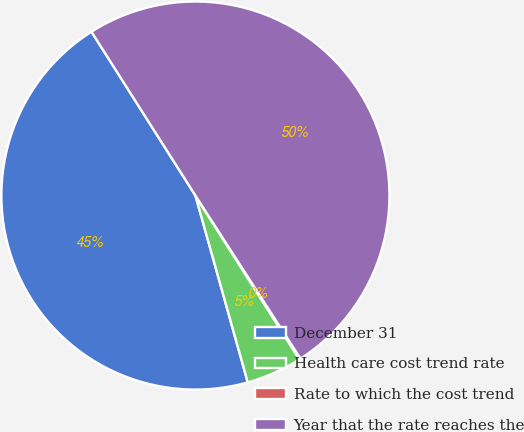Convert chart to OTSL. <chart><loc_0><loc_0><loc_500><loc_500><pie_chart><fcel>December 31<fcel>Health care cost trend rate<fcel>Rate to which the cost trend<fcel>Year that the rate reaches the<nl><fcel>45.35%<fcel>4.65%<fcel>0.11%<fcel>49.89%<nl></chart> 